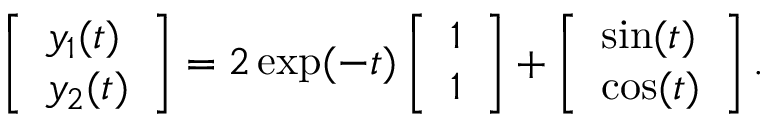Convert formula to latex. <formula><loc_0><loc_0><loc_500><loc_500>\left [ \begin{array} { l } { y _ { 1 } ( t ) } \\ { y _ { 2 } ( t ) } \end{array} \right ] = 2 \exp ( - t ) \left [ \begin{array} { l } { 1 } \\ { 1 } \end{array} \right ] + \left [ \begin{array} { l } { \sin ( t ) } \\ { \cos ( t ) } \end{array} \right ] .</formula> 